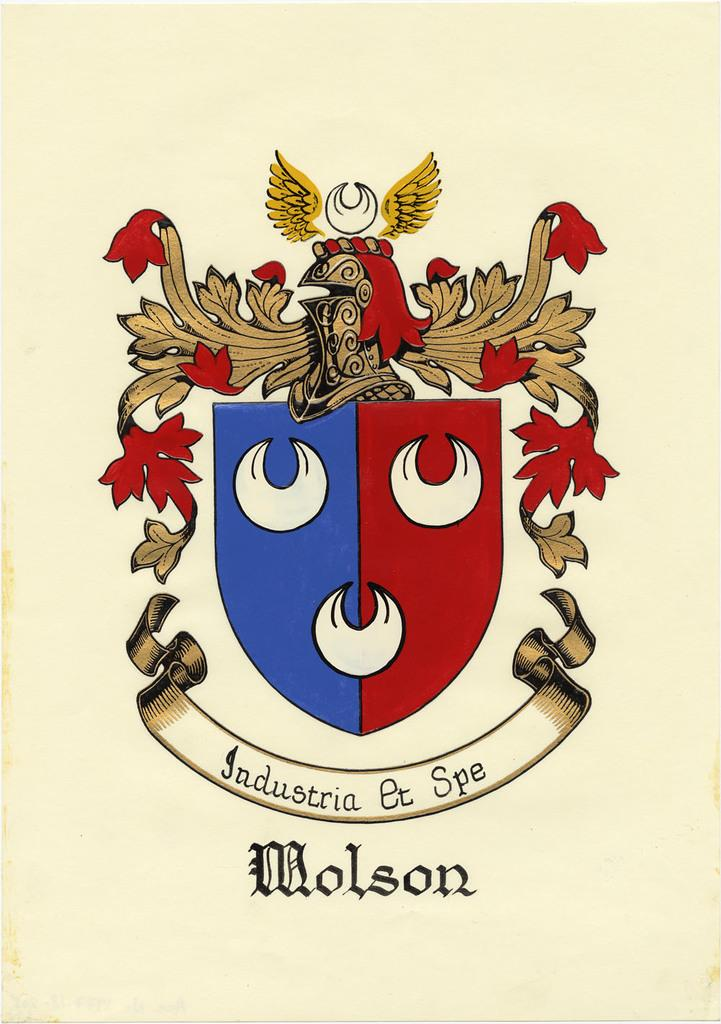<image>
Share a concise interpretation of the image provided. A crest in red, blue, tan and white has Molson below it. 